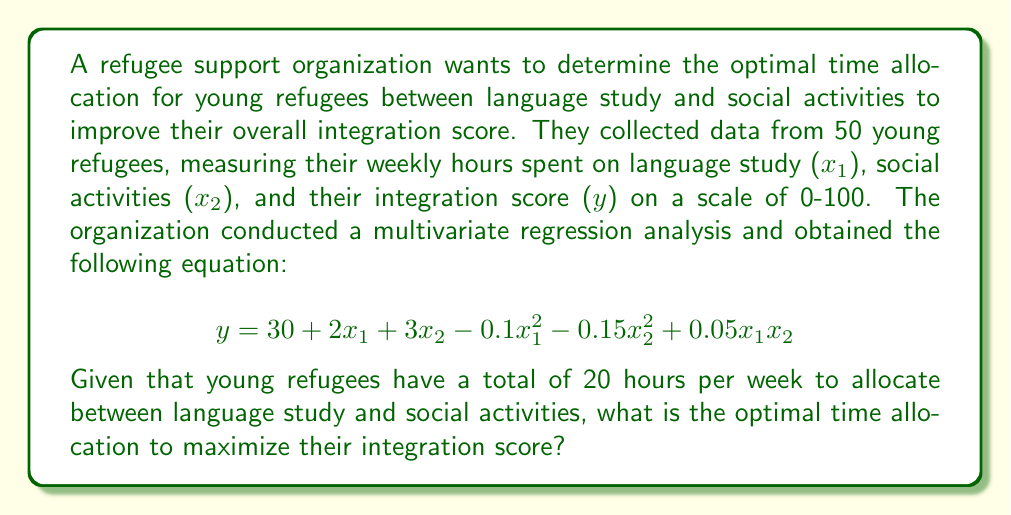Solve this math problem. To find the optimal time allocation, we need to maximize the integration score (y) subject to the constraint that the total time spent on language study and social activities is 20 hours.

1. Set up the constraint equation:
   $x_1 + x_2 = 20$

2. Substitute $x_2 = 20 - x_1$ into the regression equation:
   $y = 30 + 2x_1 + 3(20-x_1) - 0.1x_1^2 - 0.15(20-x_1)^2 + 0.05x_1(20-x_1)$

3. Expand and simplify:
   $y = 30 + 2x_1 + 60 - 3x_1 - 0.1x_1^2 - 0.15(400 - 40x_1 + x_1^2) + x_1 - 0.05x_1^2$
   $y = 90 - x_1 - 0.1x_1^2 - 60 + 6x_1 - 0.15x_1^2 + x_1 - 0.05x_1^2$
   $y = 30 + 6x_1 - 0.3x_1^2$

4. To find the maximum value of y, differentiate with respect to $x_1$ and set it to zero:
   $\frac{dy}{dx_1} = 6 - 0.6x_1 = 0$

5. Solve for $x_1$:
   $6 - 0.6x_1 = 0$
   $0.6x_1 = 6$
   $x_1 = 10$

6. Calculate $x_2$:
   $x_2 = 20 - x_1 = 20 - 10 = 10$

7. Verify that this is a maximum by checking the second derivative:
   $\frac{d^2y}{dx_1^2} = -0.6 < 0$, confirming a maximum.

Therefore, the optimal time allocation is 10 hours for language study ($x_1$) and 10 hours for social activities ($x_2$).
Answer: The optimal time allocation to maximize the integration score is 10 hours for language study and 10 hours for social activities. 